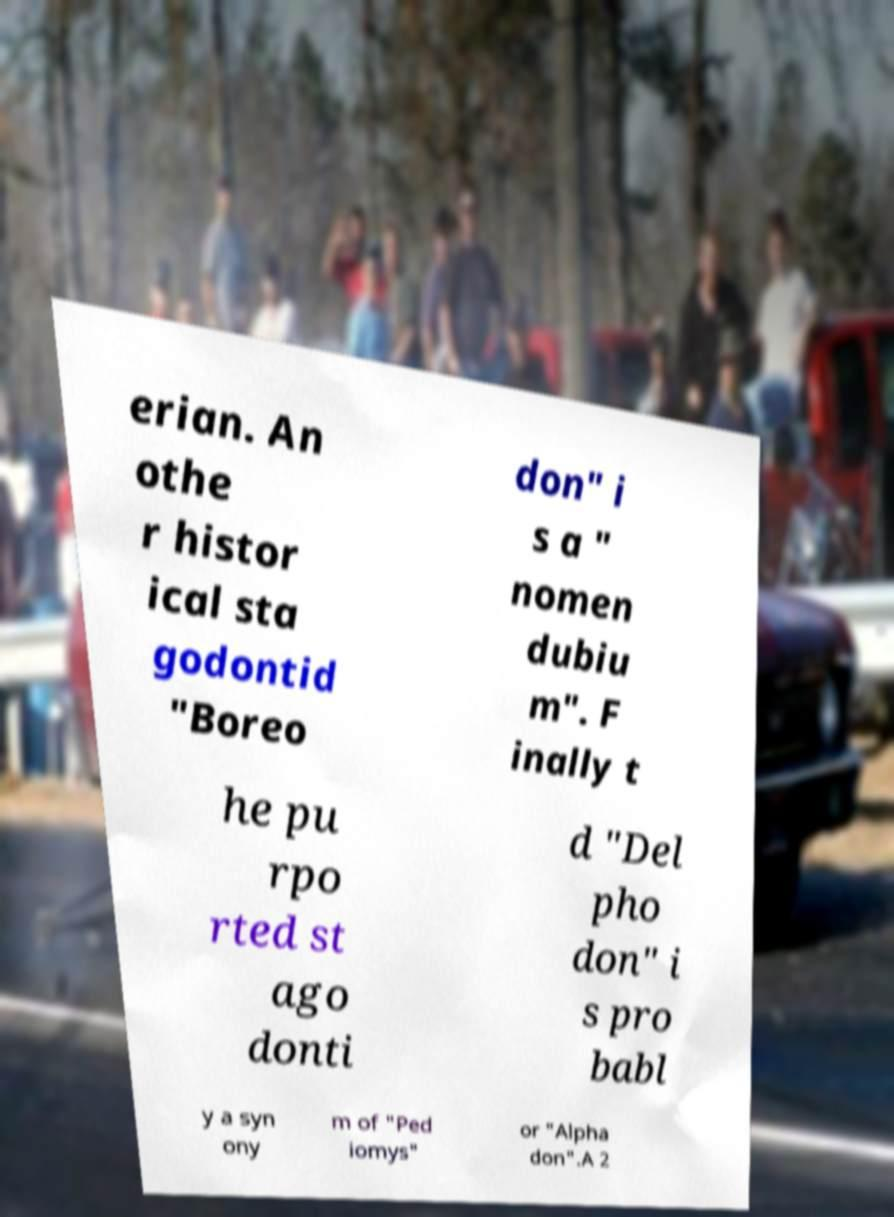Please identify and transcribe the text found in this image. erian. An othe r histor ical sta godontid "Boreo don" i s a " nomen dubiu m". F inally t he pu rpo rted st ago donti d "Del pho don" i s pro babl y a syn ony m of "Ped iomys" or "Alpha don".A 2 